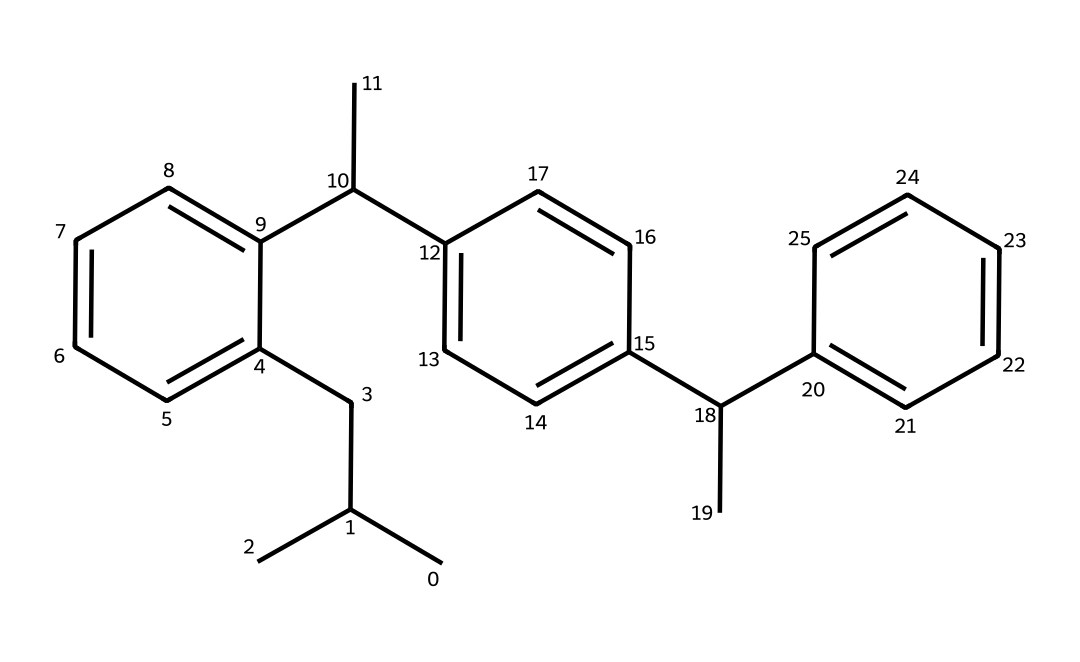What is the molecular formula of Ricin? The molecular formula can be determined by counting the number of each type of atom in the structure. By analyzing the SMILES representation, we find that Ricin consists of carbon (C) and hydrogen (H) atoms, leading us to the formula C30H48.
Answer: C30H48 How many rings are present in the Ricin structure? To find the number of rings, we need to identify cyclic portions in the chemical structure. Looking through the SMILES representation, there are several closed loops which indicate that there are three rings present.
Answer: 3 What type of molecule is Ricin classified as? This molecule can be classified by evaluating its functional groups and structure. Given its structure as a toxic protein derived from the castor bean, it is classified as a glycoprotein.
Answer: glycoprotein What element in Ricin contributes most significantly to its toxicity? The key toxic component in Ricin is a specific type of chemical structure that contains a ribosome-inactivating protein, typically involving an active site that contains a particular type of nitrogen (N). This nitrogen plays a pivotal role in its mechanism of action leading to the toxicity.
Answer: nitrogen What is the primary mechanism by which Ricin exerts its poisonous effects? Understanding the mechanism of toxicity involves recognizing how Ricin binds to cell surface receptors. It enters cells and inhibits protein synthesis by attacking ribosomes. This process indicates the biochemical pathway involved in its toxicity.
Answer: protein synthesis inhibition How does the chemical structure of Ricin allow for its use in political attacks? The significant feature of the chemical's structure is its potency as a toxin—its capacity to disable cellular machinery (through ribosome inhibition). This ability, combined with how Ricin can be aerosolized or ingested, makes it a feasible choice for biological warfare or political assassination.
Answer: potent toxin 